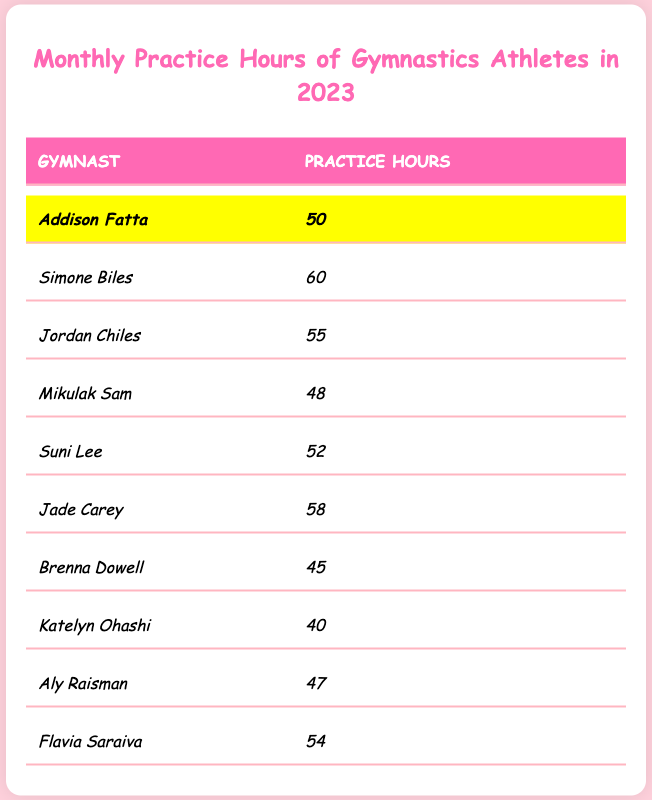What's the highest number of practice hours recorded? Reviewing the table, Simone Biles has the highest monthly practice hours at 60.
Answer: 60 Who practiced more hours, Jordan Chiles or Suni Lee? Jordan Chiles has 55 hours while Suni Lee has 52 hours. Therefore, Jordan Chiles practiced more.
Answer: Jordan Chiles What is the average practice hours of all the gymnasts listed? To find the average, sum the hours: (50 + 60 + 55 + 48 + 52 + 58 + 45 + 40 + 47 + 54) = 455. Divide by 10 (the number of gymnasts), so 455 / 10 = 45.5.
Answer: 45.5 Is Addison Fatta's practice hours equal to the average of all gymnasts? Addison Fatta's hours are 50, while the average is 45.5. Since 50 is not equal to 45.5, the statement is false.
Answer: No Which gymnast practiced the least hours and how many did they practice? Looking at the table, Katelyn Ohashi practiced the least at 40 hours.
Answer: Katelyn Ohashi, 40 hours If we focus only on the top three gymnasts based on hours practiced, what is their total practice hours? The top three are Simone Biles (60), Jade Carey (58), and Jordan Chiles (55). Their total is 60 + 58 + 55 = 173.
Answer: 173 Was the total practice hours of Brenna Dowell and Aly Raisman more than that of Mikulak Sam? Brenna Dowell has 45 hours, Aly Raisman has 47 hours, adding them gives 45 + 47 = 92 hours, while Mikulak Sam has 48 hours. Since 92 > 48, the statement is true.
Answer: Yes How many gymnasts practiced over 50 hours? From the table, the gymnasts who practiced over 50 hours are Simone Biles (60), Jordan Chiles (55), Jade Carey (58), and Flavia Saraiva (54). This makes a total of 4 gymnasts.
Answer: 4 What is the difference in practice hours between Katelyn Ohashi and Aly Raisman? Katelyn Ohashi practiced 40 hours, while Aly Raisman practiced 47 hours. The difference is 47 - 40 = 7 hours.
Answer: 7 Who are the gymnasts that practiced less than 50 hours? The gymnasts with less than 50 hours are Mikulak Sam (48), Brenna Dowell (45), and Katelyn Ohashi (40), totaling three gymnasts.
Answer: 3 